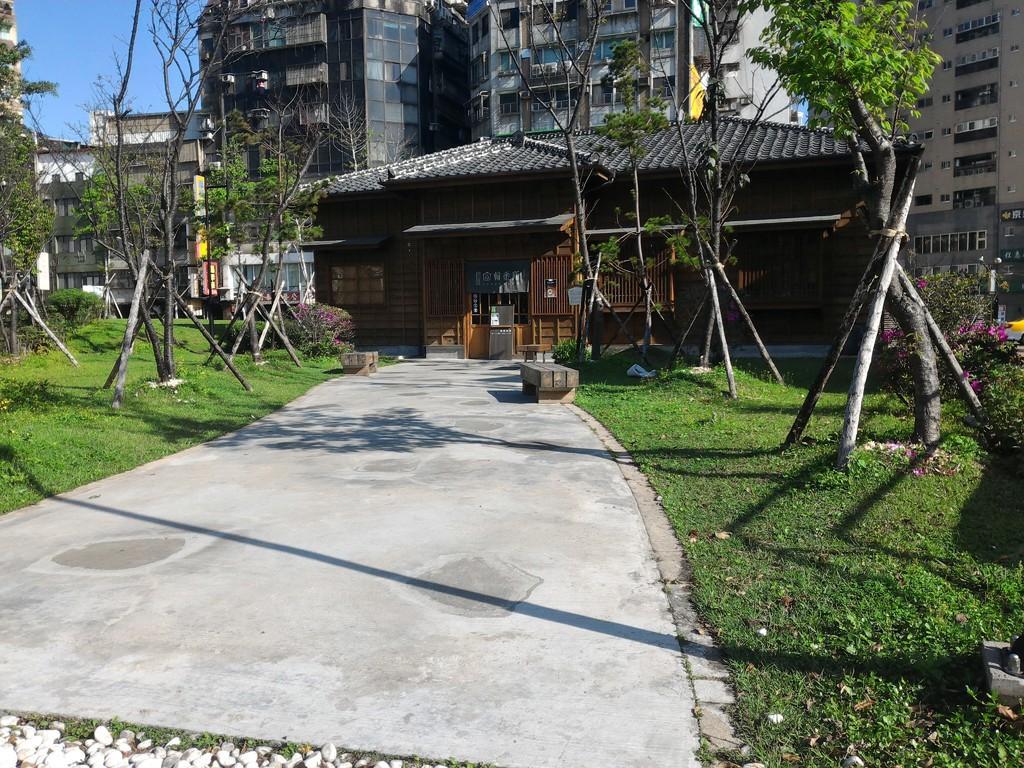Can you describe this image briefly? In this image we can see a house and behind the house we can see many buildings and also trees. Image also consists of a path and also grass. 